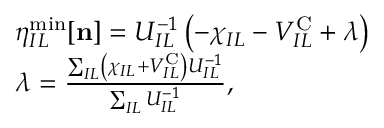Convert formula to latex. <formula><loc_0><loc_0><loc_500><loc_500>\begin{array} { r l } & { \eta _ { I L } ^ { \min } [ { n } ] = U _ { I L } ^ { - 1 } \left ( - \chi _ { I L } - V _ { I L } ^ { C } + \lambda \right ) } \\ & { \lambda = \frac { \sum _ { I L } \left ( \chi _ { I L } + V _ { I L } ^ { C } \right ) U _ { I L } ^ { - 1 } } { \sum _ { I L } U _ { I L } ^ { - 1 } } , } \end{array}</formula> 